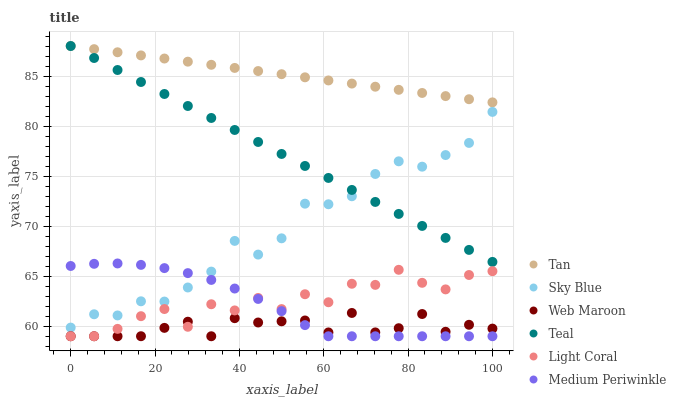Does Web Maroon have the minimum area under the curve?
Answer yes or no. Yes. Does Tan have the maximum area under the curve?
Answer yes or no. Yes. Does Light Coral have the minimum area under the curve?
Answer yes or no. No. Does Light Coral have the maximum area under the curve?
Answer yes or no. No. Is Tan the smoothest?
Answer yes or no. Yes. Is Light Coral the roughest?
Answer yes or no. Yes. Is Web Maroon the smoothest?
Answer yes or no. No. Is Web Maroon the roughest?
Answer yes or no. No. Does Medium Periwinkle have the lowest value?
Answer yes or no. Yes. Does Teal have the lowest value?
Answer yes or no. No. Does Tan have the highest value?
Answer yes or no. Yes. Does Light Coral have the highest value?
Answer yes or no. No. Is Sky Blue less than Tan?
Answer yes or no. Yes. Is Sky Blue greater than Light Coral?
Answer yes or no. Yes. Does Sky Blue intersect Medium Periwinkle?
Answer yes or no. Yes. Is Sky Blue less than Medium Periwinkle?
Answer yes or no. No. Is Sky Blue greater than Medium Periwinkle?
Answer yes or no. No. Does Sky Blue intersect Tan?
Answer yes or no. No. 